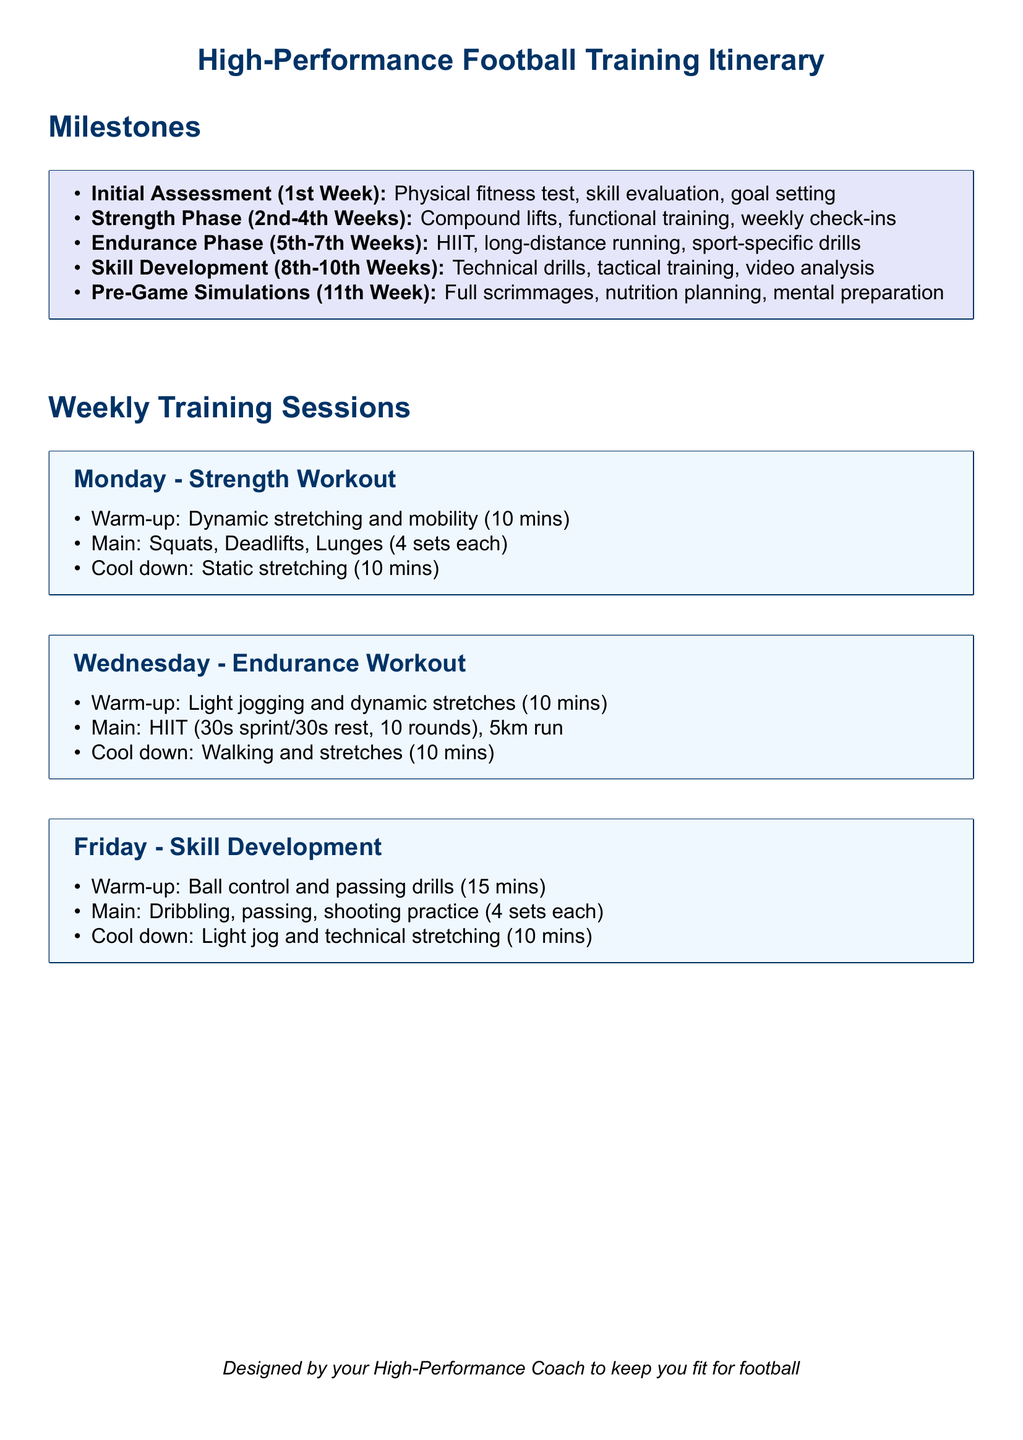what is the initial assessment week? The initial assessment includes a physical fitness test, skill evaluation, and goal setting, taking place in the first week.
Answer: 1st Week how long does the strength phase last? The strength phase lasts from the 2nd week to the 4th week, encompassing a total of three weeks.
Answer: 3 weeks what exercises are included in the Monday strength workout? The Monday strength workout includes squats, deadlifts, and lunges, with each exercise performed for 4 sets.
Answer: Squats, Deadlifts, Lunges which phase focuses on endurance training? The endurance phase focuses on training methods like HIIT and long-distance running and occurs from the 5th to the 7th week.
Answer: Endurance Phase what is the warm-up duration for the Wednesday endurance workout? The warm-up for the Wednesday endurance workout consists of light jogging and dynamic stretches for a total of 10 minutes.
Answer: 10 mins what type of drills are practiced on Friday? The Friday session focuses on skill development, specifically involving dribbling, passing, and shooting practice.
Answer: Dribbling, passing, shooting how many rounds are included in the HIIT workout on Wednesday? The HIIT workout on Wednesday consists of 10 rounds with intervals of 30 seconds of sprinting followed by 30 seconds of rest.
Answer: 10 rounds what is planned in the 11th week? In the 11th week, pre-game simulations are conducted, which include full scrimmages, nutrition planning, and mental preparation.
Answer: Pre-Game Simulations what is the color used for milestones in the document? The milestones section is highlighted with a color defined in the document as light violet.
Answer: light violet 